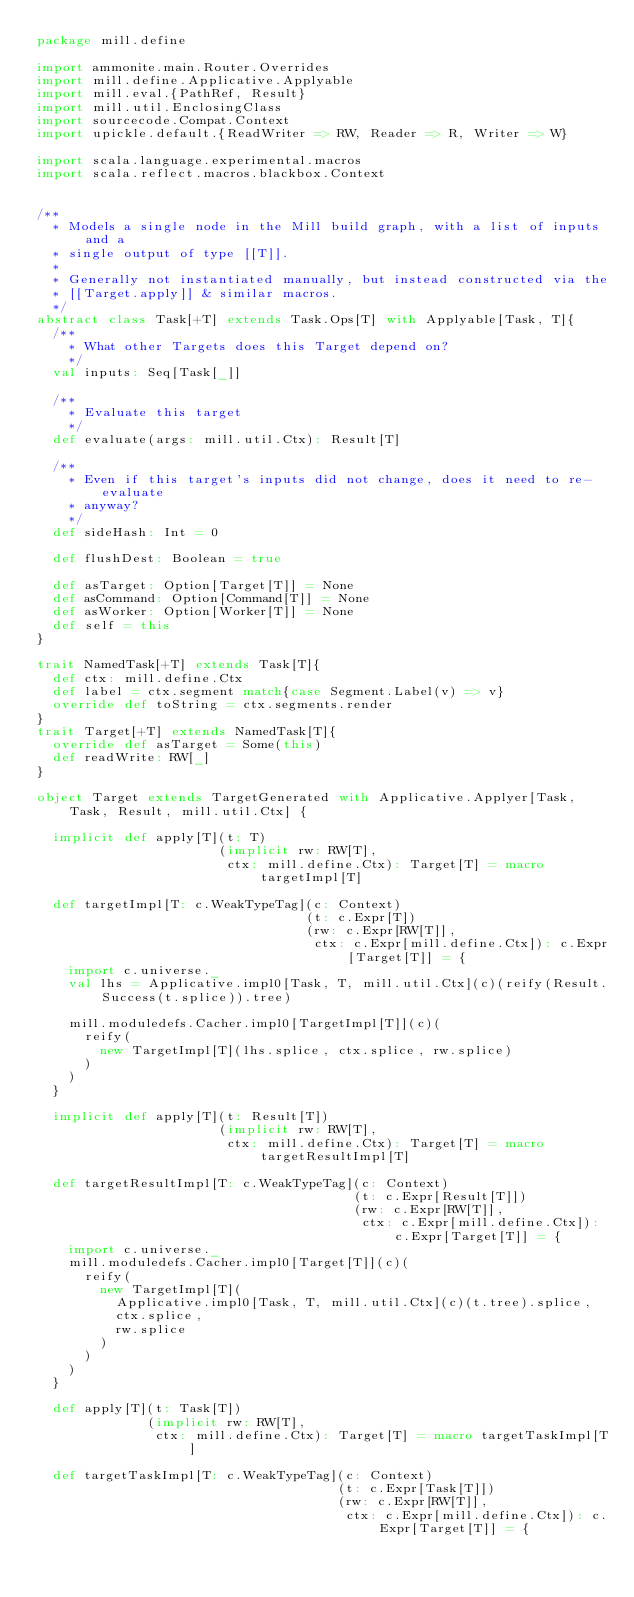Convert code to text. <code><loc_0><loc_0><loc_500><loc_500><_Scala_>package mill.define

import ammonite.main.Router.Overrides
import mill.define.Applicative.Applyable
import mill.eval.{PathRef, Result}
import mill.util.EnclosingClass
import sourcecode.Compat.Context
import upickle.default.{ReadWriter => RW, Reader => R, Writer => W}

import scala.language.experimental.macros
import scala.reflect.macros.blackbox.Context


/**
  * Models a single node in the Mill build graph, with a list of inputs and a
  * single output of type [[T]].
  *
  * Generally not instantiated manually, but instead constructed via the
  * [[Target.apply]] & similar macros.
  */
abstract class Task[+T] extends Task.Ops[T] with Applyable[Task, T]{
  /**
    * What other Targets does this Target depend on?
    */
  val inputs: Seq[Task[_]]

  /**
    * Evaluate this target
    */
  def evaluate(args: mill.util.Ctx): Result[T]

  /**
    * Even if this target's inputs did not change, does it need to re-evaluate
    * anyway?
    */
  def sideHash: Int = 0

  def flushDest: Boolean = true

  def asTarget: Option[Target[T]] = None
  def asCommand: Option[Command[T]] = None
  def asWorker: Option[Worker[T]] = None
  def self = this
}

trait NamedTask[+T] extends Task[T]{
  def ctx: mill.define.Ctx
  def label = ctx.segment match{case Segment.Label(v) => v}
  override def toString = ctx.segments.render
}
trait Target[+T] extends NamedTask[T]{
  override def asTarget = Some(this)
  def readWrite: RW[_]
}

object Target extends TargetGenerated with Applicative.Applyer[Task, Task, Result, mill.util.Ctx] {

  implicit def apply[T](t: T)
                       (implicit rw: RW[T],
                        ctx: mill.define.Ctx): Target[T] = macro targetImpl[T]

  def targetImpl[T: c.WeakTypeTag](c: Context)
                                  (t: c.Expr[T])
                                  (rw: c.Expr[RW[T]],
                                   ctx: c.Expr[mill.define.Ctx]): c.Expr[Target[T]] = {
    import c.universe._
    val lhs = Applicative.impl0[Task, T, mill.util.Ctx](c)(reify(Result.Success(t.splice)).tree)

    mill.moduledefs.Cacher.impl0[TargetImpl[T]](c)(
      reify(
        new TargetImpl[T](lhs.splice, ctx.splice, rw.splice)
      )
    )
  }

  implicit def apply[T](t: Result[T])
                       (implicit rw: RW[T],
                        ctx: mill.define.Ctx): Target[T] = macro targetResultImpl[T]

  def targetResultImpl[T: c.WeakTypeTag](c: Context)
                                        (t: c.Expr[Result[T]])
                                        (rw: c.Expr[RW[T]],
                                         ctx: c.Expr[mill.define.Ctx]): c.Expr[Target[T]] = {
    import c.universe._
    mill.moduledefs.Cacher.impl0[Target[T]](c)(
      reify(
        new TargetImpl[T](
          Applicative.impl0[Task, T, mill.util.Ctx](c)(t.tree).splice,
          ctx.splice,
          rw.splice
        )
      )
    )
  }

  def apply[T](t: Task[T])
              (implicit rw: RW[T],
               ctx: mill.define.Ctx): Target[T] = macro targetTaskImpl[T]

  def targetTaskImpl[T: c.WeakTypeTag](c: Context)
                                      (t: c.Expr[Task[T]])
                                      (rw: c.Expr[RW[T]],
                                       ctx: c.Expr[mill.define.Ctx]): c.Expr[Target[T]] = {</code> 